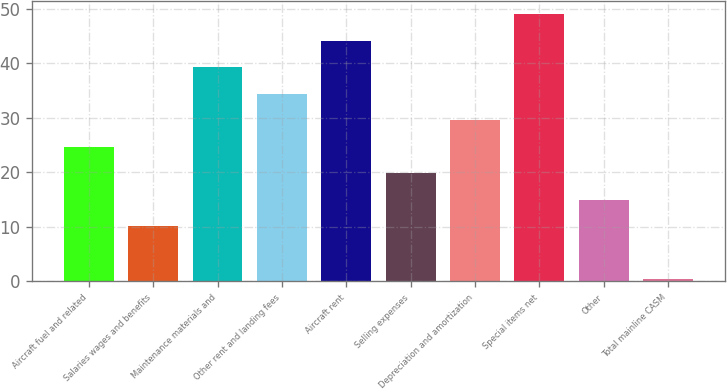<chart> <loc_0><loc_0><loc_500><loc_500><bar_chart><fcel>Aircraft fuel and related<fcel>Salaries wages and benefits<fcel>Maintenance materials and<fcel>Other rent and landing fees<fcel>Aircraft rent<fcel>Selling expenses<fcel>Depreciation and amortization<fcel>Special items net<fcel>Other<fcel>Total mainline CASM<nl><fcel>24.7<fcel>10.12<fcel>39.28<fcel>34.42<fcel>44.14<fcel>19.84<fcel>29.56<fcel>49<fcel>14.98<fcel>0.4<nl></chart> 